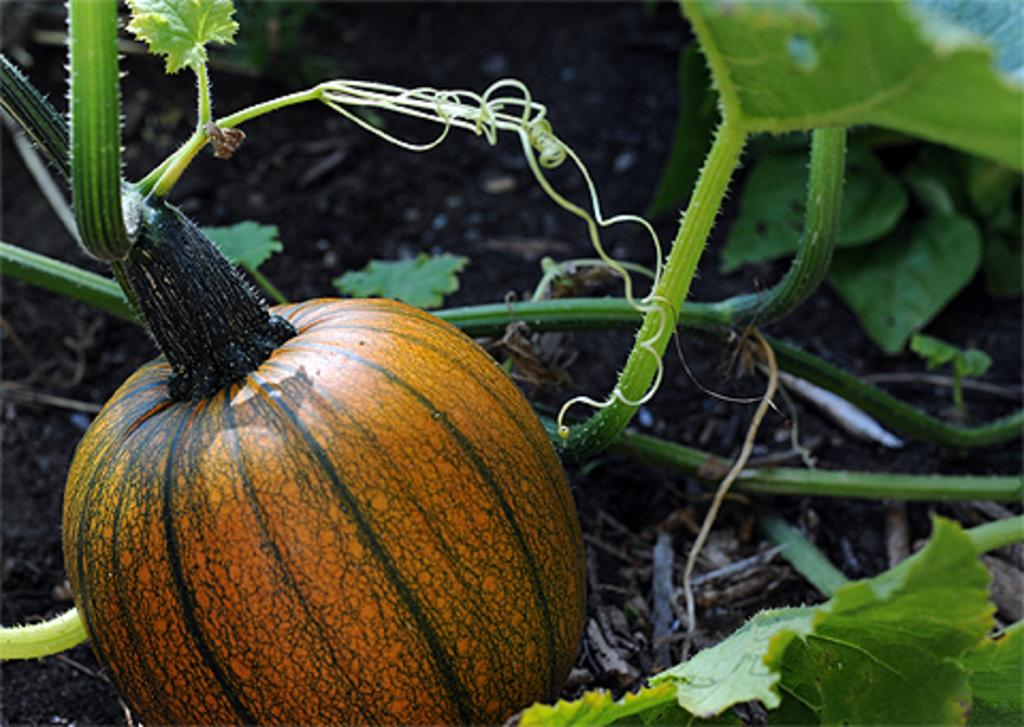What type of plant can be seen in the image? There is a pumpkin plant in the image. Where is the pumpkin plant located? The pumpkin plant is on the soil. What type of pail is hanging from the pumpkin plant in the image? There is no pail present in the image; it only features a pumpkin plant on the soil. 